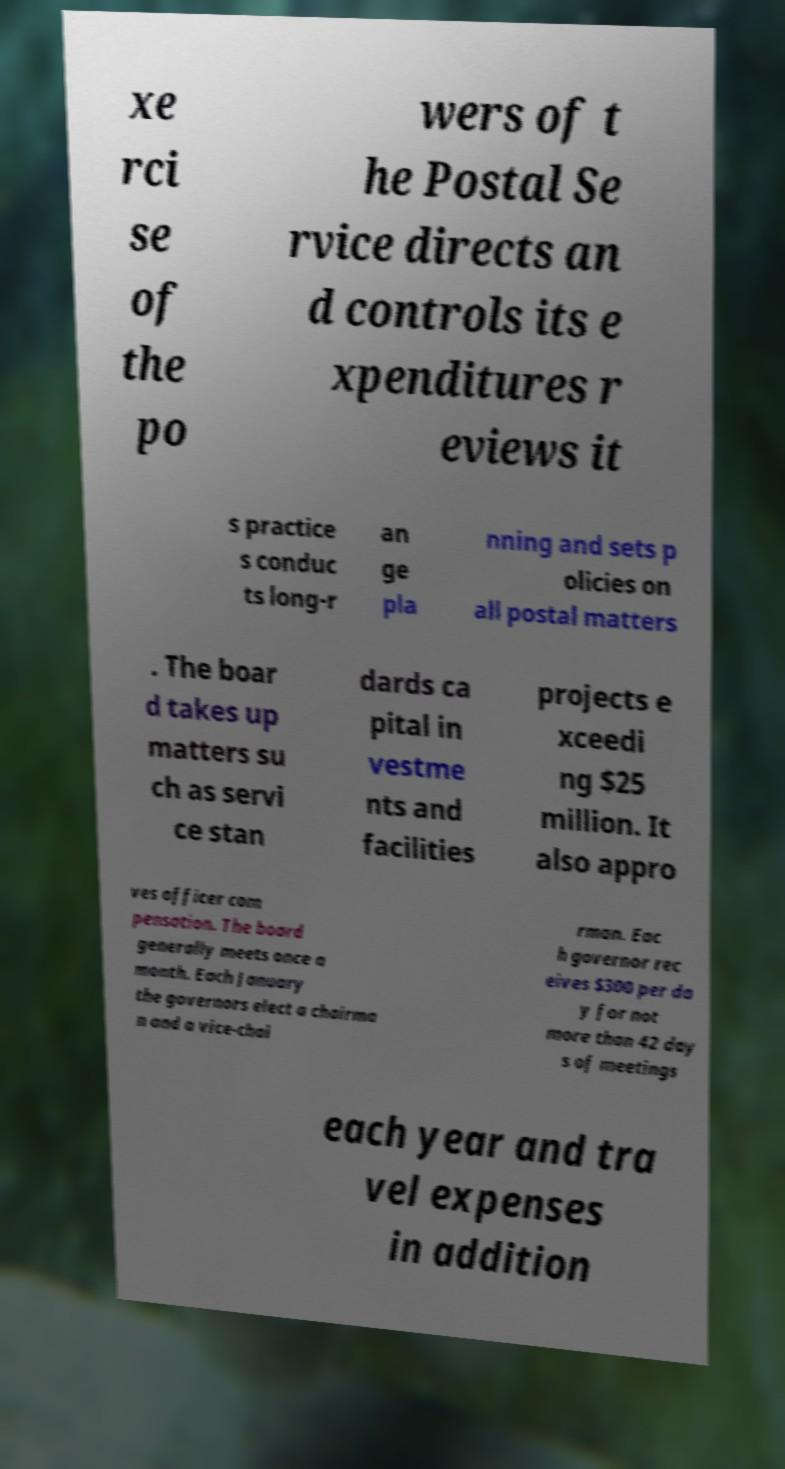Could you assist in decoding the text presented in this image and type it out clearly? xe rci se of the po wers of t he Postal Se rvice directs an d controls its e xpenditures r eviews it s practice s conduc ts long-r an ge pla nning and sets p olicies on all postal matters . The boar d takes up matters su ch as servi ce stan dards ca pital in vestme nts and facilities projects e xceedi ng $25 million. It also appro ves officer com pensation. The board generally meets once a month. Each January the governors elect a chairma n and a vice-chai rman. Eac h governor rec eives $300 per da y for not more than 42 day s of meetings each year and tra vel expenses in addition 